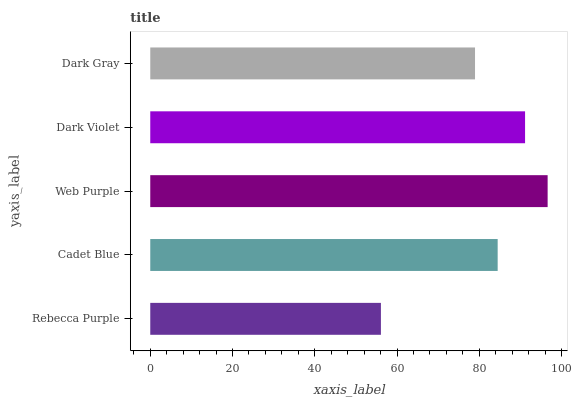Is Rebecca Purple the minimum?
Answer yes or no. Yes. Is Web Purple the maximum?
Answer yes or no. Yes. Is Cadet Blue the minimum?
Answer yes or no. No. Is Cadet Blue the maximum?
Answer yes or no. No. Is Cadet Blue greater than Rebecca Purple?
Answer yes or no. Yes. Is Rebecca Purple less than Cadet Blue?
Answer yes or no. Yes. Is Rebecca Purple greater than Cadet Blue?
Answer yes or no. No. Is Cadet Blue less than Rebecca Purple?
Answer yes or no. No. Is Cadet Blue the high median?
Answer yes or no. Yes. Is Cadet Blue the low median?
Answer yes or no. Yes. Is Dark Gray the high median?
Answer yes or no. No. Is Dark Violet the low median?
Answer yes or no. No. 